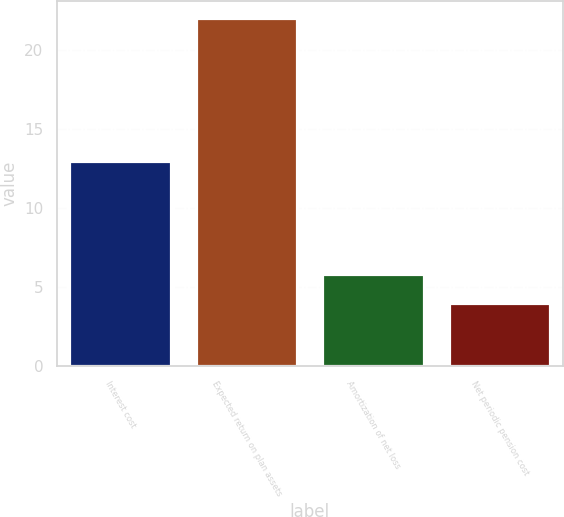Convert chart to OTSL. <chart><loc_0><loc_0><loc_500><loc_500><bar_chart><fcel>Interest cost<fcel>Expected return on plan assets<fcel>Amortization of net loss<fcel>Net periodic pension cost<nl><fcel>13<fcel>22<fcel>5.8<fcel>4<nl></chart> 